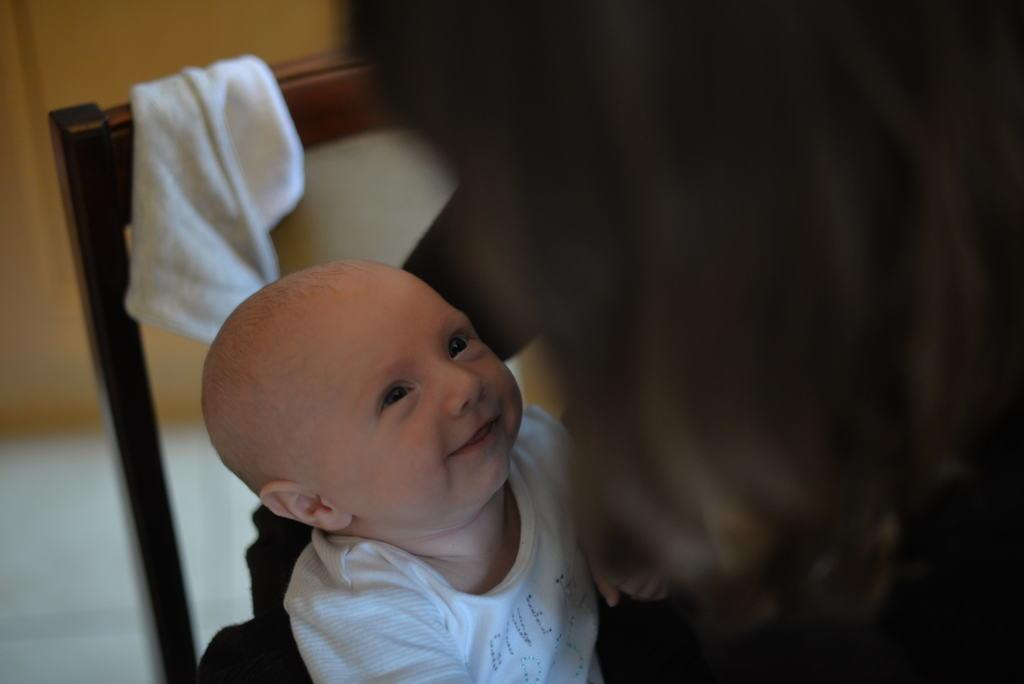Who is the main subject in the foreground of the image? There is a lady in the foreground of the image. What is the lady holding in her hand? The lady is holding a baby in her hand. Can you describe any furniture in the image? Yes, there is a chair in the image. What can be seen in the background of the image? There is a wall in the background of the image. What type of stem can be seen growing from the baby's head in the image? There is no stem growing from the baby's head in the image. What is the lady's afterthought after holding the baby in the image? The image does not provide any information about the lady's thoughts or emotions, so it is impossible to determine her afterthought. 